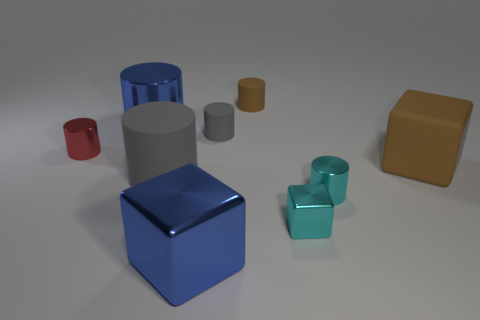Subtract all blue cylinders. How many cylinders are left? 5 Subtract all large gray cylinders. How many cylinders are left? 5 Subtract all cyan cylinders. Subtract all blue cubes. How many cylinders are left? 5 Add 1 matte cylinders. How many objects exist? 10 Subtract all blocks. How many objects are left? 6 Subtract all big metal objects. Subtract all large brown cubes. How many objects are left? 6 Add 3 gray matte cylinders. How many gray matte cylinders are left? 5 Add 7 brown matte spheres. How many brown matte spheres exist? 7 Subtract 0 purple spheres. How many objects are left? 9 